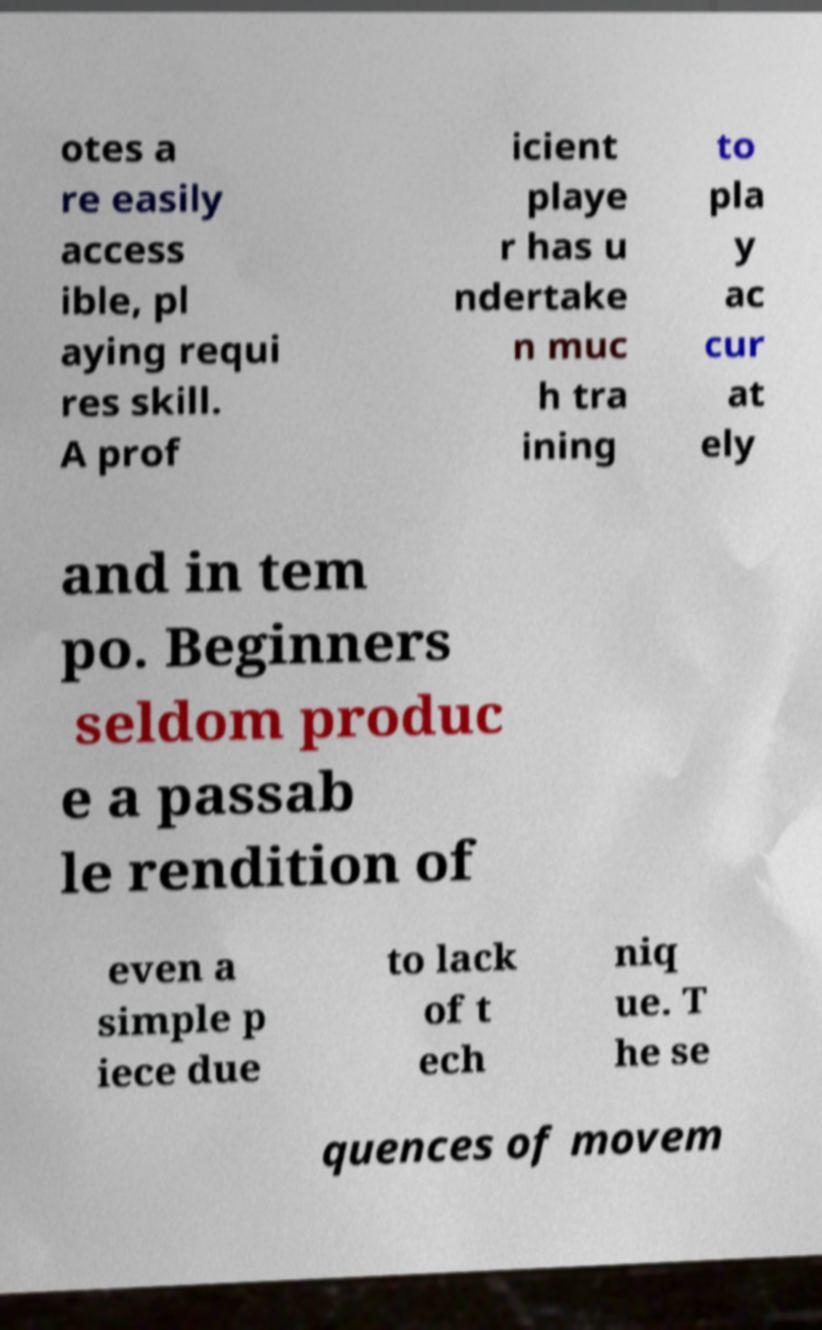For documentation purposes, I need the text within this image transcribed. Could you provide that? otes a re easily access ible, pl aying requi res skill. A prof icient playe r has u ndertake n muc h tra ining to pla y ac cur at ely and in tem po. Beginners seldom produc e a passab le rendition of even a simple p iece due to lack of t ech niq ue. T he se quences of movem 